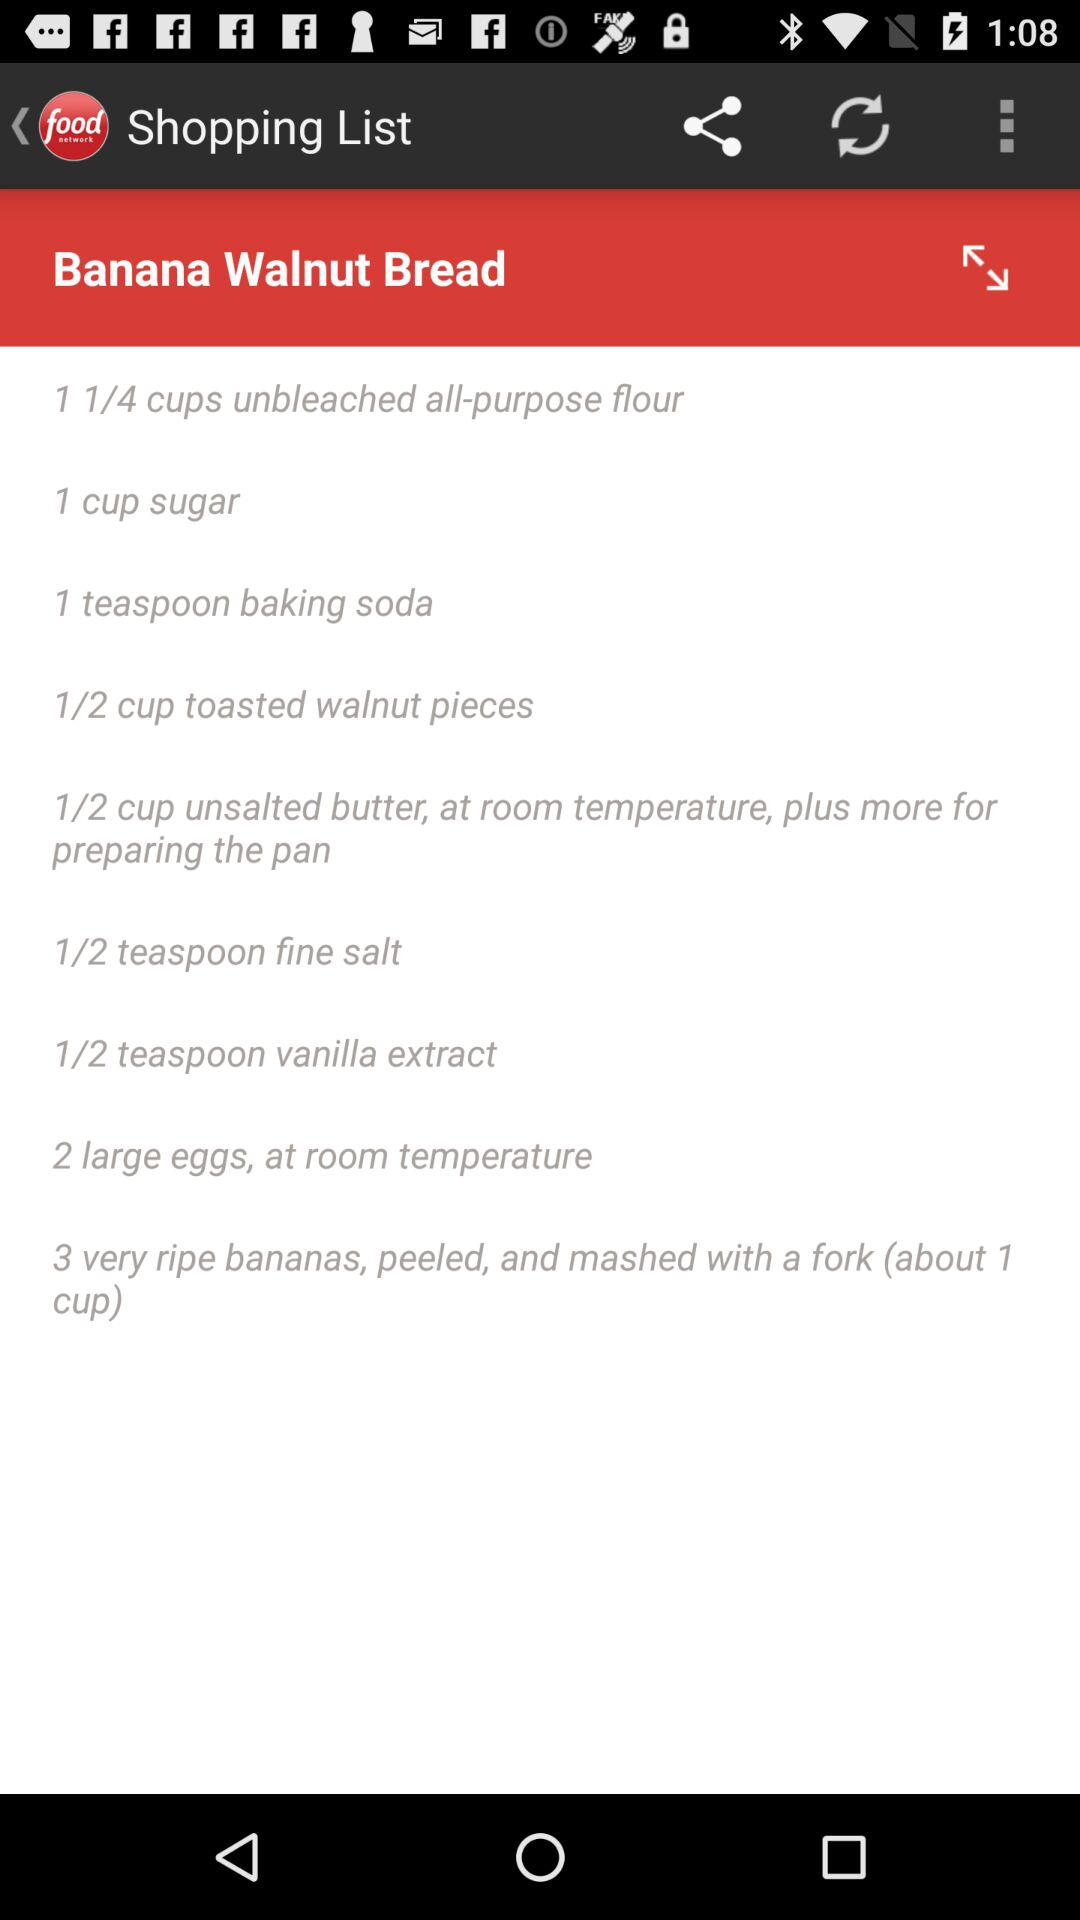What is the name of the recipe? The name of the recipe is "Banana Walnut Bread". 